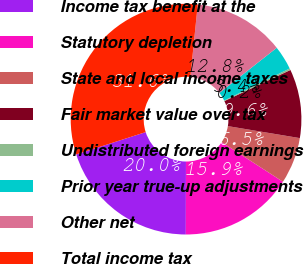Convert chart to OTSL. <chart><loc_0><loc_0><loc_500><loc_500><pie_chart><fcel>Income tax benefit at the<fcel>Statutory depletion<fcel>State and local income taxes<fcel>Fair market value over tax<fcel>Undistributed foreign earnings<fcel>Prior year true-up adjustments<fcel>Other net<fcel>Total income tax<nl><fcel>20.02%<fcel>15.9%<fcel>6.5%<fcel>9.64%<fcel>0.23%<fcel>3.37%<fcel>12.77%<fcel>31.57%<nl></chart> 